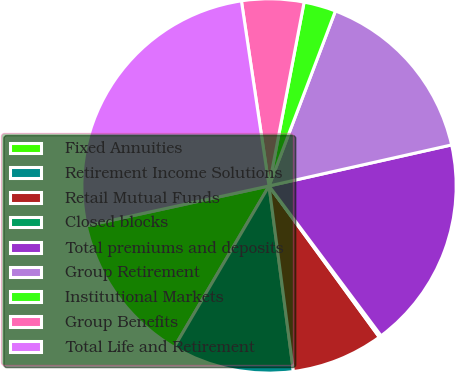<chart> <loc_0><loc_0><loc_500><loc_500><pie_chart><fcel>Fixed Annuities<fcel>Retirement Income Solutions<fcel>Retail Mutual Funds<fcel>Closed blocks<fcel>Total premiums and deposits<fcel>Group Retirement<fcel>Institutional Markets<fcel>Group Benefits<fcel>Total Life and Retirement<nl><fcel>13.12%<fcel>10.54%<fcel>7.95%<fcel>0.19%<fcel>18.3%<fcel>15.71%<fcel>2.77%<fcel>5.36%<fcel>26.06%<nl></chart> 